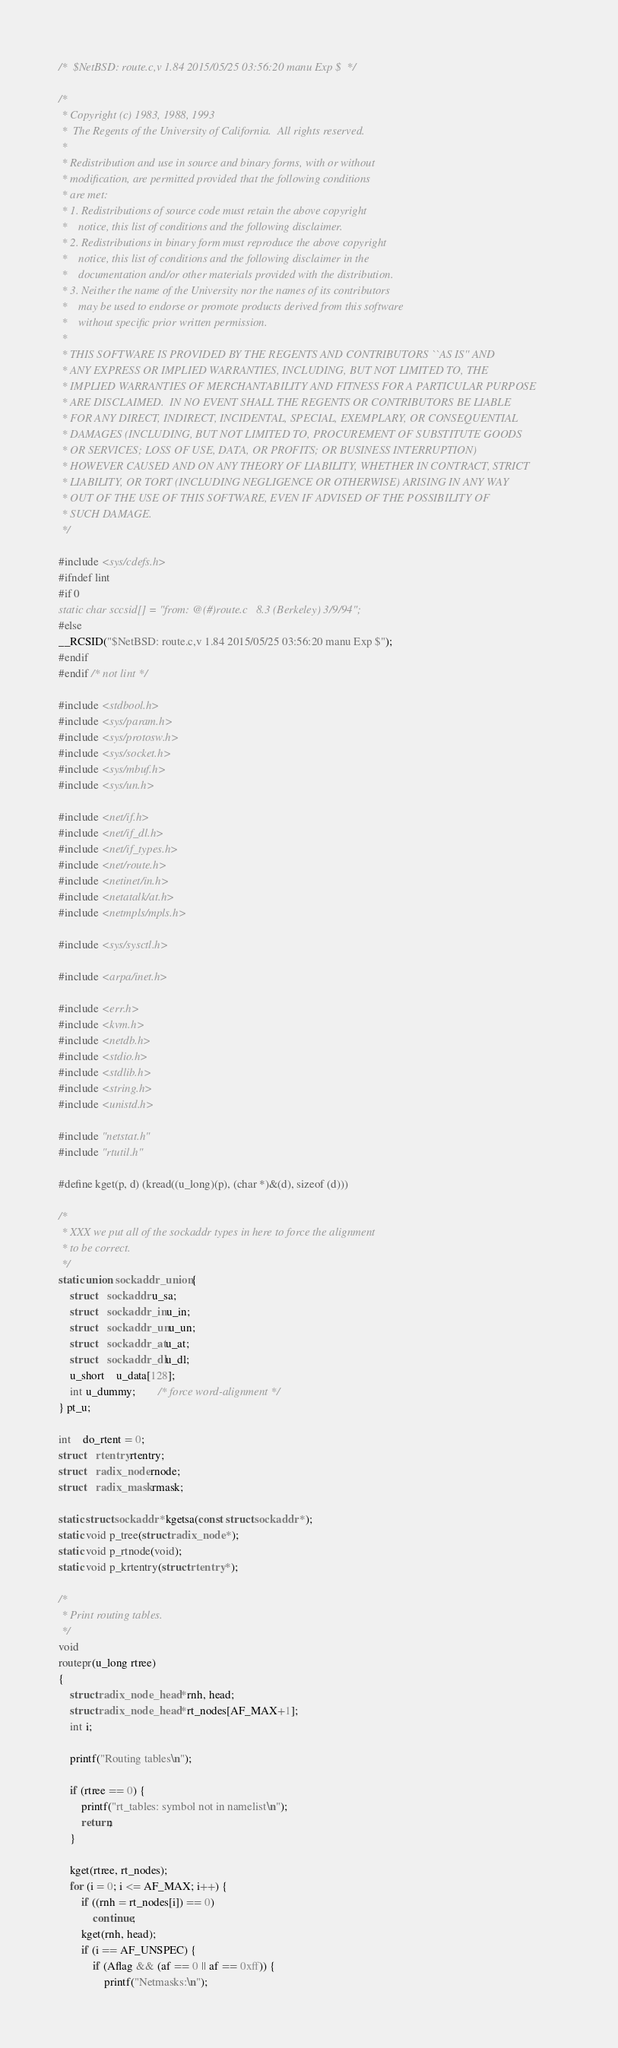Convert code to text. <code><loc_0><loc_0><loc_500><loc_500><_C_>/*	$NetBSD: route.c,v 1.84 2015/05/25 03:56:20 manu Exp $	*/

/*
 * Copyright (c) 1983, 1988, 1993
 *	The Regents of the University of California.  All rights reserved.
 *
 * Redistribution and use in source and binary forms, with or without
 * modification, are permitted provided that the following conditions
 * are met:
 * 1. Redistributions of source code must retain the above copyright
 *    notice, this list of conditions and the following disclaimer.
 * 2. Redistributions in binary form must reproduce the above copyright
 *    notice, this list of conditions and the following disclaimer in the
 *    documentation and/or other materials provided with the distribution.
 * 3. Neither the name of the University nor the names of its contributors
 *    may be used to endorse or promote products derived from this software
 *    without specific prior written permission.
 *
 * THIS SOFTWARE IS PROVIDED BY THE REGENTS AND CONTRIBUTORS ``AS IS'' AND
 * ANY EXPRESS OR IMPLIED WARRANTIES, INCLUDING, BUT NOT LIMITED TO, THE
 * IMPLIED WARRANTIES OF MERCHANTABILITY AND FITNESS FOR A PARTICULAR PURPOSE
 * ARE DISCLAIMED.  IN NO EVENT SHALL THE REGENTS OR CONTRIBUTORS BE LIABLE
 * FOR ANY DIRECT, INDIRECT, INCIDENTAL, SPECIAL, EXEMPLARY, OR CONSEQUENTIAL
 * DAMAGES (INCLUDING, BUT NOT LIMITED TO, PROCUREMENT OF SUBSTITUTE GOODS
 * OR SERVICES; LOSS OF USE, DATA, OR PROFITS; OR BUSINESS INTERRUPTION)
 * HOWEVER CAUSED AND ON ANY THEORY OF LIABILITY, WHETHER IN CONTRACT, STRICT
 * LIABILITY, OR TORT (INCLUDING NEGLIGENCE OR OTHERWISE) ARISING IN ANY WAY
 * OUT OF THE USE OF THIS SOFTWARE, EVEN IF ADVISED OF THE POSSIBILITY OF
 * SUCH DAMAGE.
 */

#include <sys/cdefs.h>
#ifndef lint
#if 0
static char sccsid[] = "from: @(#)route.c	8.3 (Berkeley) 3/9/94";
#else
__RCSID("$NetBSD: route.c,v 1.84 2015/05/25 03:56:20 manu Exp $");
#endif
#endif /* not lint */

#include <stdbool.h>
#include <sys/param.h>
#include <sys/protosw.h>
#include <sys/socket.h>
#include <sys/mbuf.h>
#include <sys/un.h>

#include <net/if.h>
#include <net/if_dl.h>
#include <net/if_types.h>
#include <net/route.h>
#include <netinet/in.h>
#include <netatalk/at.h>
#include <netmpls/mpls.h>

#include <sys/sysctl.h>

#include <arpa/inet.h>

#include <err.h>
#include <kvm.h>
#include <netdb.h>
#include <stdio.h>
#include <stdlib.h>
#include <string.h>
#include <unistd.h>

#include "netstat.h"
#include "rtutil.h"

#define kget(p, d) (kread((u_long)(p), (char *)&(d), sizeof (d)))

/*
 * XXX we put all of the sockaddr types in here to force the alignment
 * to be correct.
 */
static union sockaddr_union {
	struct	sockaddr u_sa;
	struct	sockaddr_in u_in;
	struct	sockaddr_un u_un;
	struct	sockaddr_at u_at;
	struct	sockaddr_dl u_dl;
	u_short	u_data[128];
	int u_dummy;		/* force word-alignment */
} pt_u;

int	do_rtent = 0;
struct	rtentry rtentry;
struct	radix_node rnode;
struct	radix_mask rmask;

static struct sockaddr *kgetsa(const struct sockaddr *);
static void p_tree(struct radix_node *);
static void p_rtnode(void);
static void p_krtentry(struct rtentry *);

/*
 * Print routing tables.
 */
void
routepr(u_long rtree)
{
	struct radix_node_head *rnh, head;
	struct radix_node_head *rt_nodes[AF_MAX+1];
	int i;

	printf("Routing tables\n");

	if (rtree == 0) {
		printf("rt_tables: symbol not in namelist\n");
		return;
	}

	kget(rtree, rt_nodes);
	for (i = 0; i <= AF_MAX; i++) {
		if ((rnh = rt_nodes[i]) == 0)
			continue;
		kget(rnh, head);
		if (i == AF_UNSPEC) {
			if (Aflag && (af == 0 || af == 0xff)) {
				printf("Netmasks:\n");</code> 